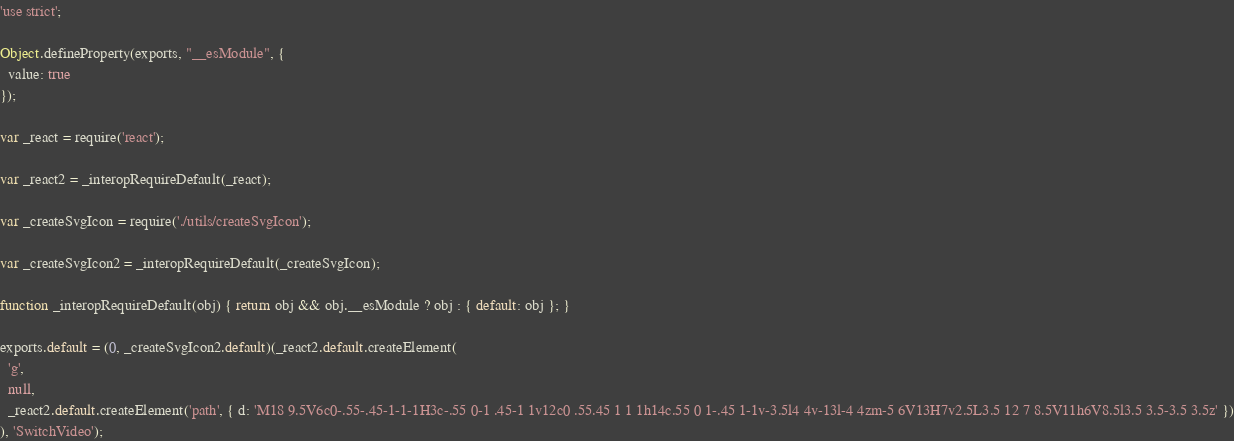<code> <loc_0><loc_0><loc_500><loc_500><_JavaScript_>'use strict';

Object.defineProperty(exports, "__esModule", {
  value: true
});

var _react = require('react');

var _react2 = _interopRequireDefault(_react);

var _createSvgIcon = require('./utils/createSvgIcon');

var _createSvgIcon2 = _interopRequireDefault(_createSvgIcon);

function _interopRequireDefault(obj) { return obj && obj.__esModule ? obj : { default: obj }; }

exports.default = (0, _createSvgIcon2.default)(_react2.default.createElement(
  'g',
  null,
  _react2.default.createElement('path', { d: 'M18 9.5V6c0-.55-.45-1-1-1H3c-.55 0-1 .45-1 1v12c0 .55.45 1 1 1h14c.55 0 1-.45 1-1v-3.5l4 4v-13l-4 4zm-5 6V13H7v2.5L3.5 12 7 8.5V11h6V8.5l3.5 3.5-3.5 3.5z' })
), 'SwitchVideo');</code> 